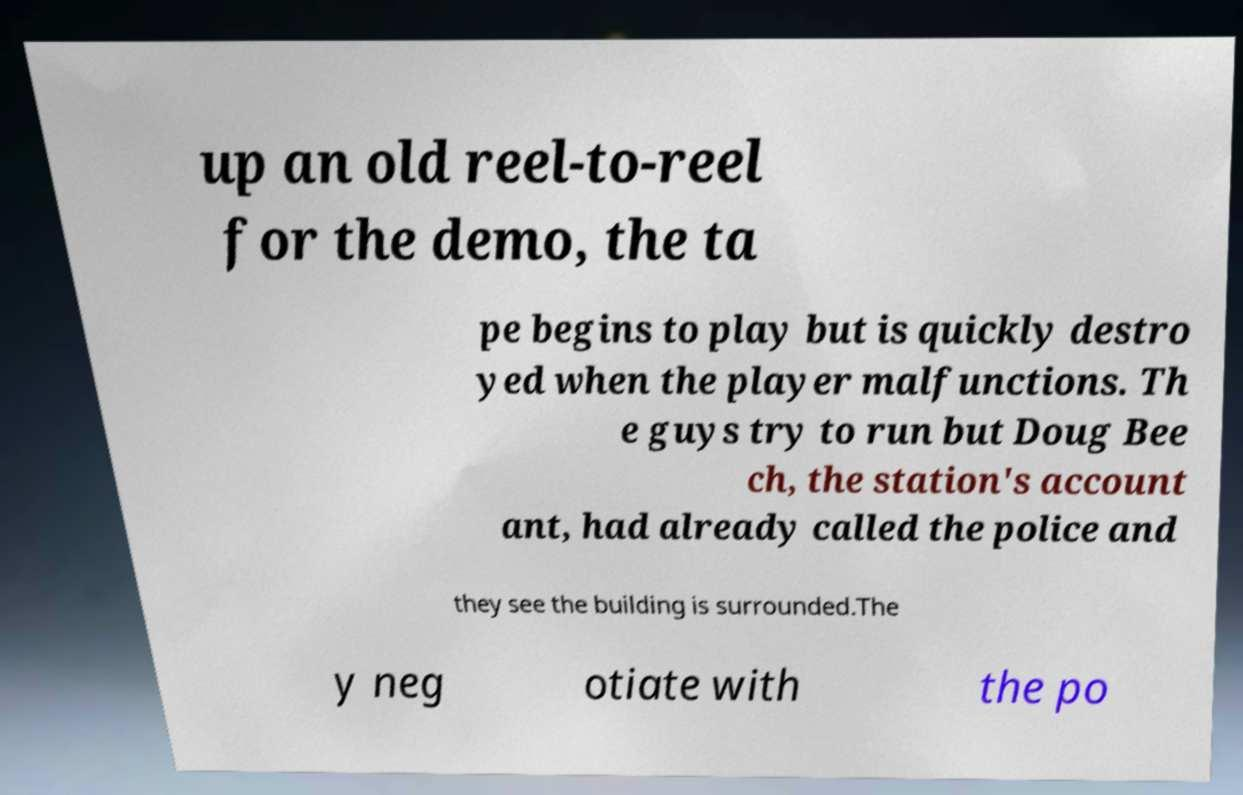There's text embedded in this image that I need extracted. Can you transcribe it verbatim? up an old reel-to-reel for the demo, the ta pe begins to play but is quickly destro yed when the player malfunctions. Th e guys try to run but Doug Bee ch, the station's account ant, had already called the police and they see the building is surrounded.The y neg otiate with the po 